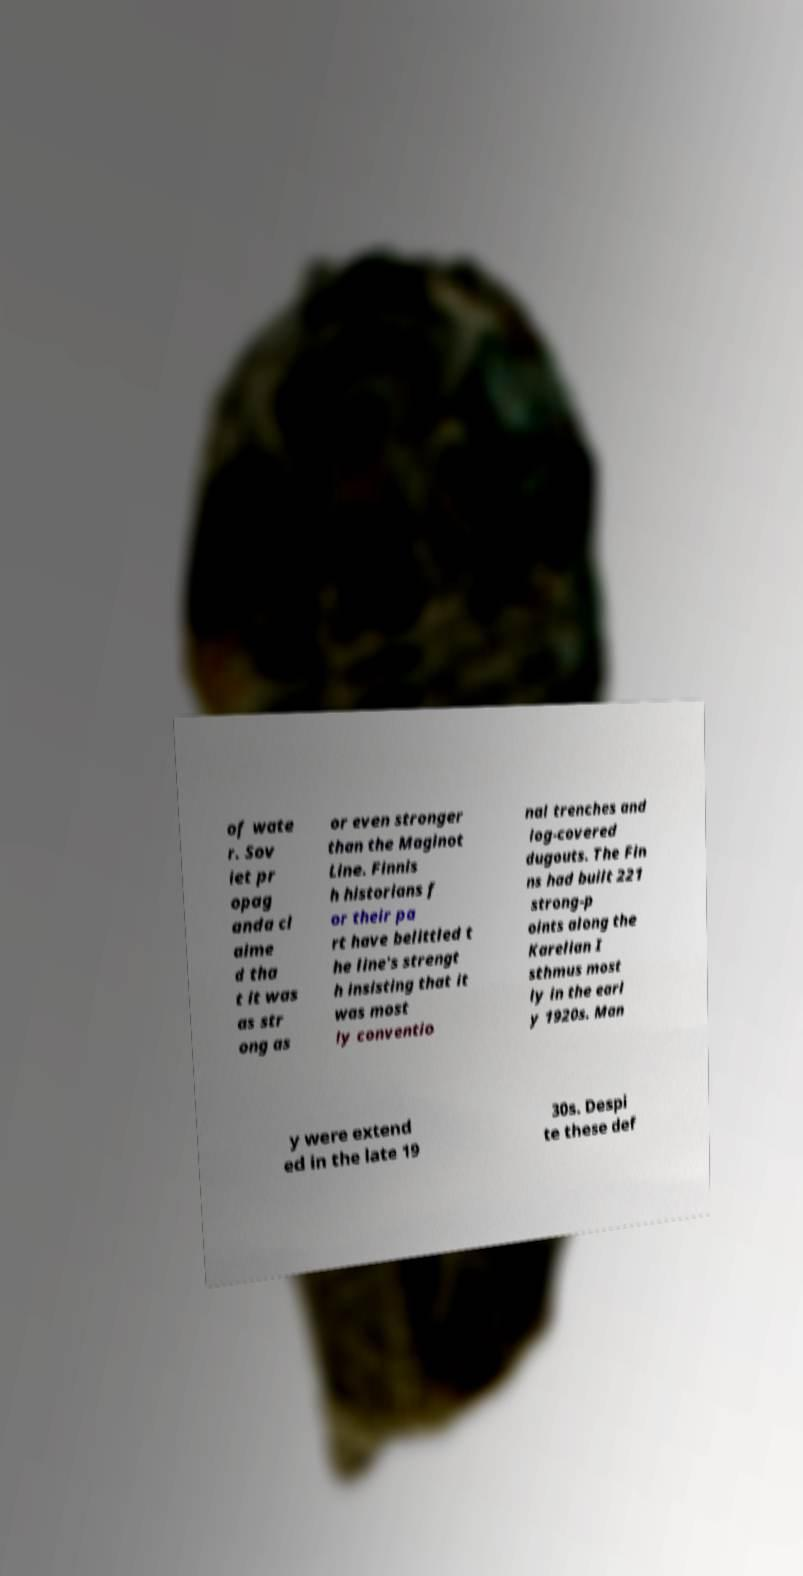What messages or text are displayed in this image? I need them in a readable, typed format. of wate r. Sov iet pr opag anda cl aime d tha t it was as str ong as or even stronger than the Maginot Line. Finnis h historians f or their pa rt have belittled t he line's strengt h insisting that it was most ly conventio nal trenches and log-covered dugouts. The Fin ns had built 221 strong-p oints along the Karelian I sthmus most ly in the earl y 1920s. Man y were extend ed in the late 19 30s. Despi te these def 